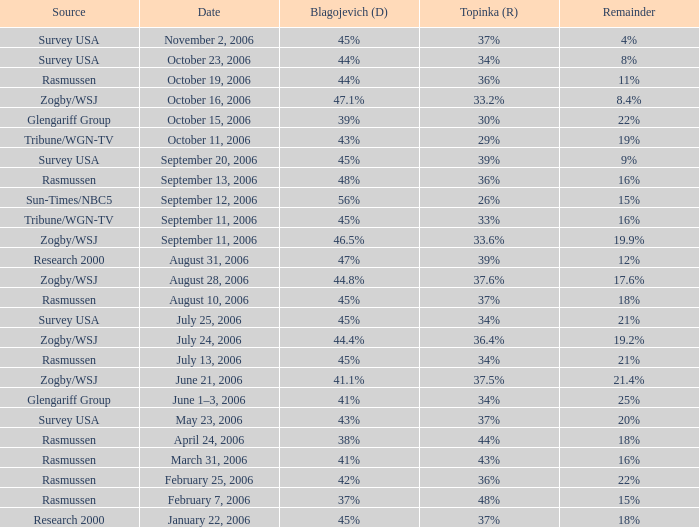Which Source has a Remainder of 15%, and a Topinka of 26%? Sun-Times/NBC5. 